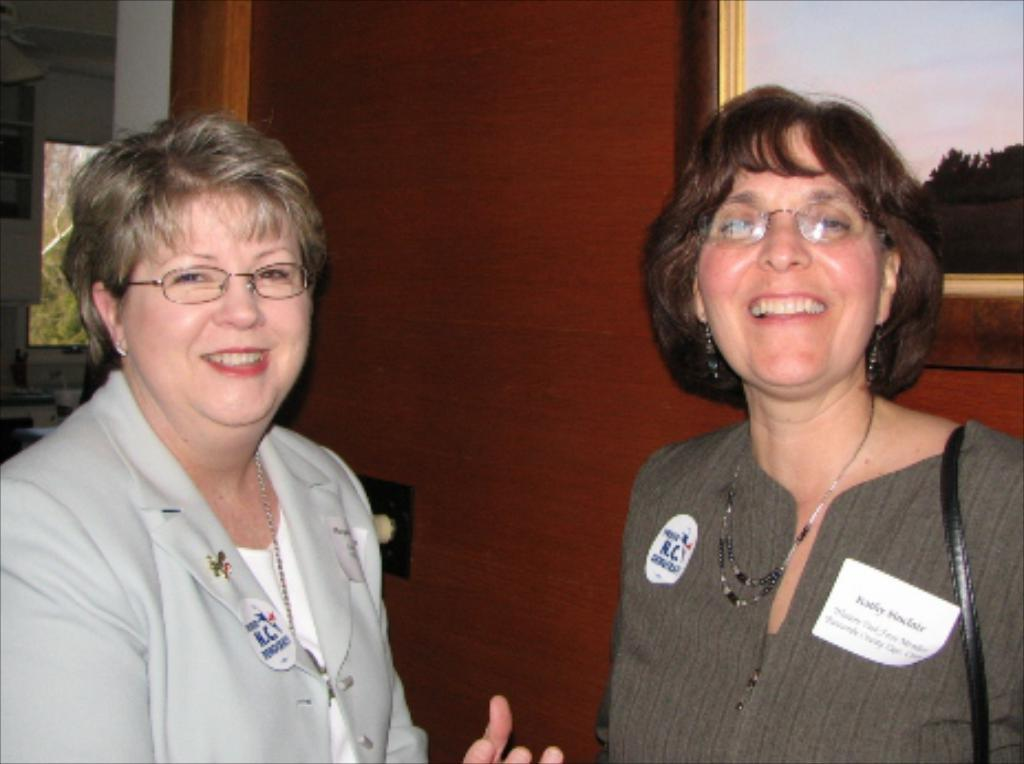What can be observed about the women in the image? There are women standing in the image, and they are smiling. What architectural features can be seen in the background of the image? There is a door, a wall, and a window in the background of the image. What is visible outside the window? Trees are visible outside the window. What type of writer is visible in the image? There is no writer present in the image. What need is being addressed by the women in the image? The image does not provide information about any specific needs being addressed by the women. 